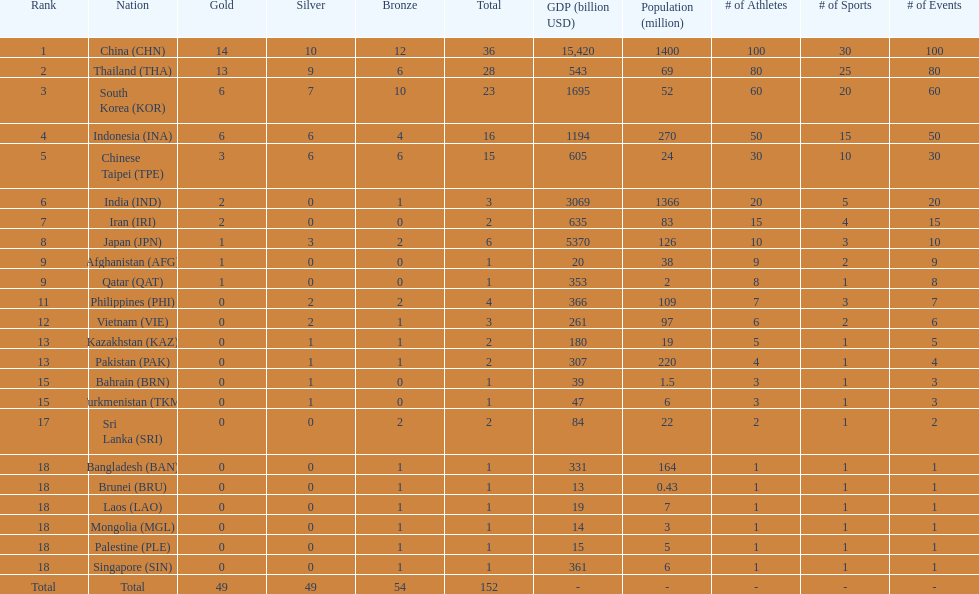How many nations received more than 5 gold medals? 4. 